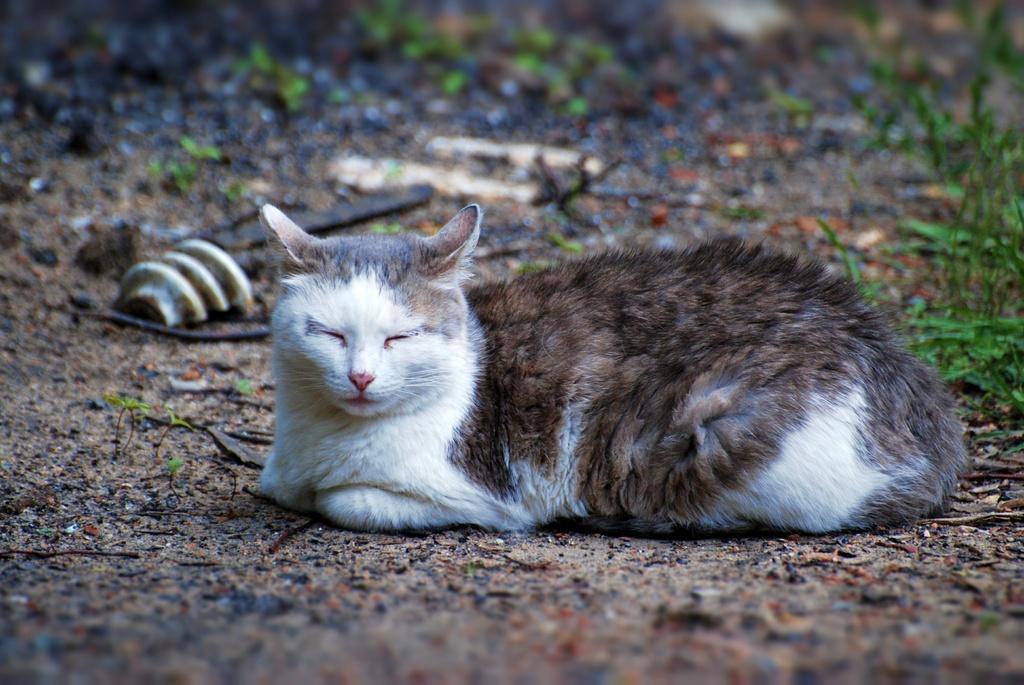Describe this image in one or two sentences. This image is taken outdoors. At the bottom of the image there is a ground with grass and dry leaves on it. In the middle of the image there is a cat on the ground. 